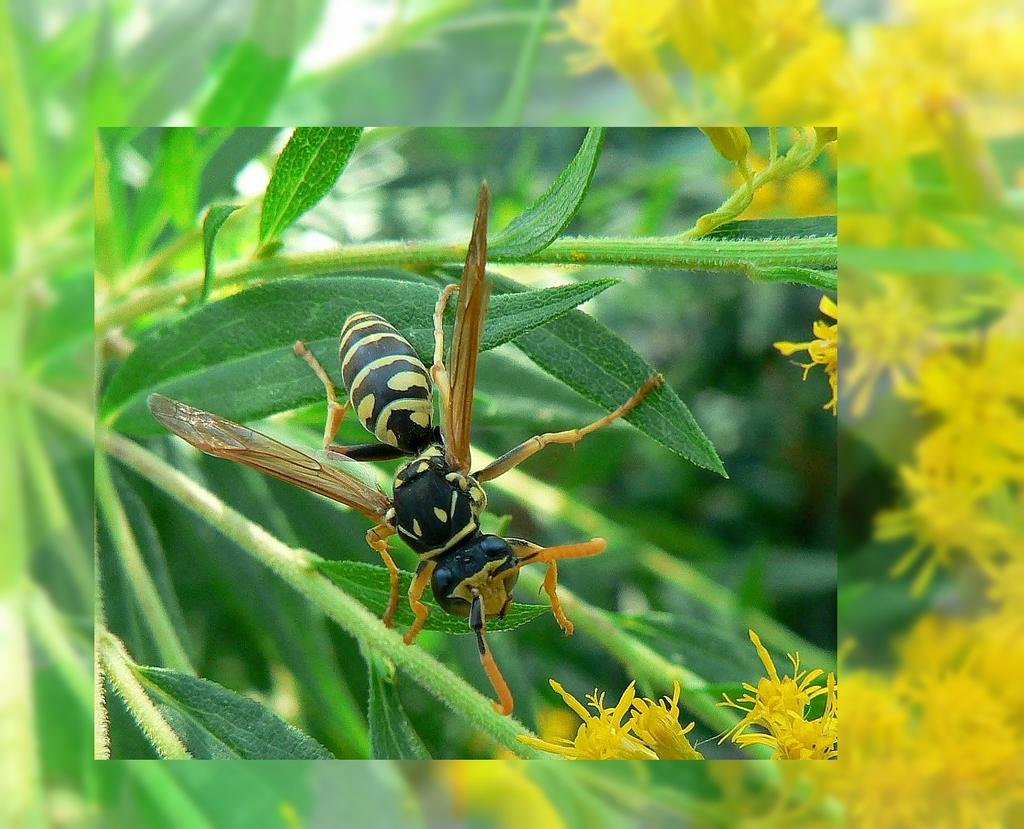What is the main subject in the foreground of the image? There is a bee on a leaf in the foreground of the image. What type of flowers can be seen in the image? There are yellow flowers visible in the image. What else is present in the image besides the bee and flowers? There are leaves present in the image. What color is the arm of the person holding the balloon in the image? There is no person holding a balloon in the image; it only features a bee, yellow flowers, and leaves. How much dirt is visible on the leaves in the image? There is no dirt visible on the leaves in the image; the leaves appear clean. 